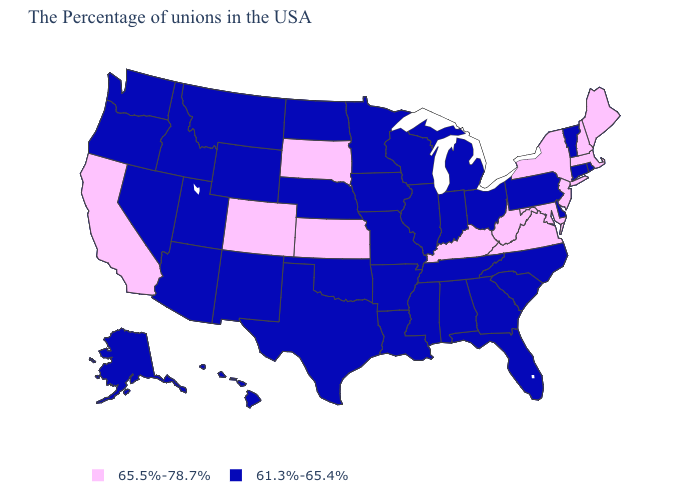What is the value of Arizona?
Give a very brief answer. 61.3%-65.4%. Name the states that have a value in the range 61.3%-65.4%?
Answer briefly. Rhode Island, Vermont, Connecticut, Delaware, Pennsylvania, North Carolina, South Carolina, Ohio, Florida, Georgia, Michigan, Indiana, Alabama, Tennessee, Wisconsin, Illinois, Mississippi, Louisiana, Missouri, Arkansas, Minnesota, Iowa, Nebraska, Oklahoma, Texas, North Dakota, Wyoming, New Mexico, Utah, Montana, Arizona, Idaho, Nevada, Washington, Oregon, Alaska, Hawaii. Name the states that have a value in the range 61.3%-65.4%?
Concise answer only. Rhode Island, Vermont, Connecticut, Delaware, Pennsylvania, North Carolina, South Carolina, Ohio, Florida, Georgia, Michigan, Indiana, Alabama, Tennessee, Wisconsin, Illinois, Mississippi, Louisiana, Missouri, Arkansas, Minnesota, Iowa, Nebraska, Oklahoma, Texas, North Dakota, Wyoming, New Mexico, Utah, Montana, Arizona, Idaho, Nevada, Washington, Oregon, Alaska, Hawaii. What is the value of Texas?
Concise answer only. 61.3%-65.4%. What is the lowest value in states that border Indiana?
Keep it brief. 61.3%-65.4%. Name the states that have a value in the range 61.3%-65.4%?
Write a very short answer. Rhode Island, Vermont, Connecticut, Delaware, Pennsylvania, North Carolina, South Carolina, Ohio, Florida, Georgia, Michigan, Indiana, Alabama, Tennessee, Wisconsin, Illinois, Mississippi, Louisiana, Missouri, Arkansas, Minnesota, Iowa, Nebraska, Oklahoma, Texas, North Dakota, Wyoming, New Mexico, Utah, Montana, Arizona, Idaho, Nevada, Washington, Oregon, Alaska, Hawaii. Name the states that have a value in the range 65.5%-78.7%?
Answer briefly. Maine, Massachusetts, New Hampshire, New York, New Jersey, Maryland, Virginia, West Virginia, Kentucky, Kansas, South Dakota, Colorado, California. What is the lowest value in states that border Alabama?
Quick response, please. 61.3%-65.4%. Name the states that have a value in the range 65.5%-78.7%?
Quick response, please. Maine, Massachusetts, New Hampshire, New York, New Jersey, Maryland, Virginia, West Virginia, Kentucky, Kansas, South Dakota, Colorado, California. Which states hav the highest value in the South?
Write a very short answer. Maryland, Virginia, West Virginia, Kentucky. What is the lowest value in states that border Oregon?
Be succinct. 61.3%-65.4%. Does Colorado have the highest value in the West?
Quick response, please. Yes. Which states have the highest value in the USA?
Be succinct. Maine, Massachusetts, New Hampshire, New York, New Jersey, Maryland, Virginia, West Virginia, Kentucky, Kansas, South Dakota, Colorado, California. What is the value of Idaho?
Write a very short answer. 61.3%-65.4%. What is the value of Louisiana?
Short answer required. 61.3%-65.4%. 